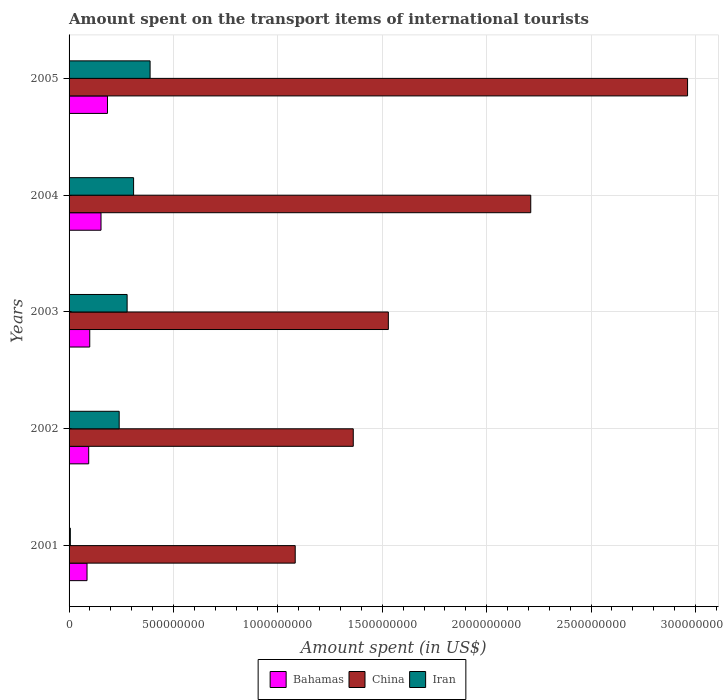How many different coloured bars are there?
Your answer should be compact. 3. How many groups of bars are there?
Make the answer very short. 5. What is the label of the 2nd group of bars from the top?
Give a very brief answer. 2004. In how many cases, is the number of bars for a given year not equal to the number of legend labels?
Provide a short and direct response. 0. What is the amount spent on the transport items of international tourists in Bahamas in 2002?
Ensure brevity in your answer.  9.40e+07. Across all years, what is the maximum amount spent on the transport items of international tourists in China?
Keep it short and to the point. 2.96e+09. Across all years, what is the minimum amount spent on the transport items of international tourists in Bahamas?
Give a very brief answer. 8.60e+07. In which year was the amount spent on the transport items of international tourists in Iran maximum?
Your answer should be very brief. 2005. In which year was the amount spent on the transport items of international tourists in Bahamas minimum?
Keep it short and to the point. 2001. What is the total amount spent on the transport items of international tourists in Iran in the graph?
Give a very brief answer. 1.22e+09. What is the difference between the amount spent on the transport items of international tourists in Bahamas in 2002 and that in 2003?
Make the answer very short. -5.00e+06. What is the difference between the amount spent on the transport items of international tourists in Bahamas in 2005 and the amount spent on the transport items of international tourists in China in 2003?
Keep it short and to the point. -1.34e+09. What is the average amount spent on the transport items of international tourists in Iran per year?
Give a very brief answer. 2.44e+08. In the year 2001, what is the difference between the amount spent on the transport items of international tourists in Iran and amount spent on the transport items of international tourists in Bahamas?
Your answer should be very brief. -8.00e+07. What is the ratio of the amount spent on the transport items of international tourists in Bahamas in 2002 to that in 2005?
Give a very brief answer. 0.51. Is the difference between the amount spent on the transport items of international tourists in Iran in 2002 and 2004 greater than the difference between the amount spent on the transport items of international tourists in Bahamas in 2002 and 2004?
Your answer should be very brief. No. What is the difference between the highest and the second highest amount spent on the transport items of international tourists in China?
Ensure brevity in your answer.  7.51e+08. What is the difference between the highest and the lowest amount spent on the transport items of international tourists in Iran?
Ensure brevity in your answer.  3.82e+08. In how many years, is the amount spent on the transport items of international tourists in China greater than the average amount spent on the transport items of international tourists in China taken over all years?
Your response must be concise. 2. Is the sum of the amount spent on the transport items of international tourists in China in 2001 and 2005 greater than the maximum amount spent on the transport items of international tourists in Bahamas across all years?
Give a very brief answer. Yes. What does the 3rd bar from the top in 2002 represents?
Offer a very short reply. Bahamas. Is it the case that in every year, the sum of the amount spent on the transport items of international tourists in Iran and amount spent on the transport items of international tourists in China is greater than the amount spent on the transport items of international tourists in Bahamas?
Your response must be concise. Yes. How many years are there in the graph?
Offer a terse response. 5. Where does the legend appear in the graph?
Your response must be concise. Bottom center. What is the title of the graph?
Your response must be concise. Amount spent on the transport items of international tourists. What is the label or title of the X-axis?
Your response must be concise. Amount spent (in US$). What is the label or title of the Y-axis?
Provide a succinct answer. Years. What is the Amount spent (in US$) in Bahamas in 2001?
Give a very brief answer. 8.60e+07. What is the Amount spent (in US$) in China in 2001?
Provide a short and direct response. 1.08e+09. What is the Amount spent (in US$) of Iran in 2001?
Make the answer very short. 6.00e+06. What is the Amount spent (in US$) in Bahamas in 2002?
Keep it short and to the point. 9.40e+07. What is the Amount spent (in US$) of China in 2002?
Ensure brevity in your answer.  1.36e+09. What is the Amount spent (in US$) of Iran in 2002?
Your answer should be very brief. 2.40e+08. What is the Amount spent (in US$) in Bahamas in 2003?
Give a very brief answer. 9.90e+07. What is the Amount spent (in US$) of China in 2003?
Ensure brevity in your answer.  1.53e+09. What is the Amount spent (in US$) of Iran in 2003?
Offer a very short reply. 2.78e+08. What is the Amount spent (in US$) in Bahamas in 2004?
Your answer should be compact. 1.53e+08. What is the Amount spent (in US$) in China in 2004?
Provide a short and direct response. 2.21e+09. What is the Amount spent (in US$) in Iran in 2004?
Give a very brief answer. 3.09e+08. What is the Amount spent (in US$) in Bahamas in 2005?
Make the answer very short. 1.84e+08. What is the Amount spent (in US$) in China in 2005?
Provide a succinct answer. 2.96e+09. What is the Amount spent (in US$) in Iran in 2005?
Offer a very short reply. 3.88e+08. Across all years, what is the maximum Amount spent (in US$) in Bahamas?
Give a very brief answer. 1.84e+08. Across all years, what is the maximum Amount spent (in US$) of China?
Offer a very short reply. 2.96e+09. Across all years, what is the maximum Amount spent (in US$) in Iran?
Give a very brief answer. 3.88e+08. Across all years, what is the minimum Amount spent (in US$) in Bahamas?
Your response must be concise. 8.60e+07. Across all years, what is the minimum Amount spent (in US$) in China?
Offer a terse response. 1.08e+09. Across all years, what is the minimum Amount spent (in US$) in Iran?
Offer a terse response. 6.00e+06. What is the total Amount spent (in US$) of Bahamas in the graph?
Offer a very short reply. 6.16e+08. What is the total Amount spent (in US$) in China in the graph?
Your answer should be compact. 9.15e+09. What is the total Amount spent (in US$) in Iran in the graph?
Ensure brevity in your answer.  1.22e+09. What is the difference between the Amount spent (in US$) in Bahamas in 2001 and that in 2002?
Offer a very short reply. -8.00e+06. What is the difference between the Amount spent (in US$) in China in 2001 and that in 2002?
Your answer should be very brief. -2.78e+08. What is the difference between the Amount spent (in US$) in Iran in 2001 and that in 2002?
Make the answer very short. -2.34e+08. What is the difference between the Amount spent (in US$) of Bahamas in 2001 and that in 2003?
Provide a succinct answer. -1.30e+07. What is the difference between the Amount spent (in US$) in China in 2001 and that in 2003?
Provide a short and direct response. -4.46e+08. What is the difference between the Amount spent (in US$) of Iran in 2001 and that in 2003?
Provide a succinct answer. -2.72e+08. What is the difference between the Amount spent (in US$) of Bahamas in 2001 and that in 2004?
Your answer should be very brief. -6.70e+07. What is the difference between the Amount spent (in US$) in China in 2001 and that in 2004?
Give a very brief answer. -1.13e+09. What is the difference between the Amount spent (in US$) in Iran in 2001 and that in 2004?
Provide a succinct answer. -3.03e+08. What is the difference between the Amount spent (in US$) of Bahamas in 2001 and that in 2005?
Provide a succinct answer. -9.80e+07. What is the difference between the Amount spent (in US$) of China in 2001 and that in 2005?
Ensure brevity in your answer.  -1.88e+09. What is the difference between the Amount spent (in US$) of Iran in 2001 and that in 2005?
Give a very brief answer. -3.82e+08. What is the difference between the Amount spent (in US$) in Bahamas in 2002 and that in 2003?
Offer a terse response. -5.00e+06. What is the difference between the Amount spent (in US$) of China in 2002 and that in 2003?
Keep it short and to the point. -1.68e+08. What is the difference between the Amount spent (in US$) of Iran in 2002 and that in 2003?
Make the answer very short. -3.80e+07. What is the difference between the Amount spent (in US$) of Bahamas in 2002 and that in 2004?
Your answer should be very brief. -5.90e+07. What is the difference between the Amount spent (in US$) of China in 2002 and that in 2004?
Make the answer very short. -8.50e+08. What is the difference between the Amount spent (in US$) in Iran in 2002 and that in 2004?
Give a very brief answer. -6.90e+07. What is the difference between the Amount spent (in US$) in Bahamas in 2002 and that in 2005?
Provide a succinct answer. -9.00e+07. What is the difference between the Amount spent (in US$) in China in 2002 and that in 2005?
Your response must be concise. -1.60e+09. What is the difference between the Amount spent (in US$) of Iran in 2002 and that in 2005?
Your answer should be compact. -1.48e+08. What is the difference between the Amount spent (in US$) in Bahamas in 2003 and that in 2004?
Ensure brevity in your answer.  -5.40e+07. What is the difference between the Amount spent (in US$) of China in 2003 and that in 2004?
Give a very brief answer. -6.82e+08. What is the difference between the Amount spent (in US$) of Iran in 2003 and that in 2004?
Your response must be concise. -3.10e+07. What is the difference between the Amount spent (in US$) of Bahamas in 2003 and that in 2005?
Provide a succinct answer. -8.50e+07. What is the difference between the Amount spent (in US$) in China in 2003 and that in 2005?
Ensure brevity in your answer.  -1.43e+09. What is the difference between the Amount spent (in US$) in Iran in 2003 and that in 2005?
Offer a terse response. -1.10e+08. What is the difference between the Amount spent (in US$) of Bahamas in 2004 and that in 2005?
Offer a very short reply. -3.10e+07. What is the difference between the Amount spent (in US$) of China in 2004 and that in 2005?
Provide a short and direct response. -7.51e+08. What is the difference between the Amount spent (in US$) of Iran in 2004 and that in 2005?
Keep it short and to the point. -7.90e+07. What is the difference between the Amount spent (in US$) of Bahamas in 2001 and the Amount spent (in US$) of China in 2002?
Offer a very short reply. -1.28e+09. What is the difference between the Amount spent (in US$) in Bahamas in 2001 and the Amount spent (in US$) in Iran in 2002?
Ensure brevity in your answer.  -1.54e+08. What is the difference between the Amount spent (in US$) of China in 2001 and the Amount spent (in US$) of Iran in 2002?
Provide a succinct answer. 8.43e+08. What is the difference between the Amount spent (in US$) in Bahamas in 2001 and the Amount spent (in US$) in China in 2003?
Keep it short and to the point. -1.44e+09. What is the difference between the Amount spent (in US$) of Bahamas in 2001 and the Amount spent (in US$) of Iran in 2003?
Offer a terse response. -1.92e+08. What is the difference between the Amount spent (in US$) of China in 2001 and the Amount spent (in US$) of Iran in 2003?
Make the answer very short. 8.05e+08. What is the difference between the Amount spent (in US$) of Bahamas in 2001 and the Amount spent (in US$) of China in 2004?
Your answer should be compact. -2.12e+09. What is the difference between the Amount spent (in US$) in Bahamas in 2001 and the Amount spent (in US$) in Iran in 2004?
Your response must be concise. -2.23e+08. What is the difference between the Amount spent (in US$) in China in 2001 and the Amount spent (in US$) in Iran in 2004?
Keep it short and to the point. 7.74e+08. What is the difference between the Amount spent (in US$) in Bahamas in 2001 and the Amount spent (in US$) in China in 2005?
Offer a very short reply. -2.88e+09. What is the difference between the Amount spent (in US$) in Bahamas in 2001 and the Amount spent (in US$) in Iran in 2005?
Offer a very short reply. -3.02e+08. What is the difference between the Amount spent (in US$) in China in 2001 and the Amount spent (in US$) in Iran in 2005?
Provide a short and direct response. 6.95e+08. What is the difference between the Amount spent (in US$) in Bahamas in 2002 and the Amount spent (in US$) in China in 2003?
Offer a terse response. -1.44e+09. What is the difference between the Amount spent (in US$) of Bahamas in 2002 and the Amount spent (in US$) of Iran in 2003?
Ensure brevity in your answer.  -1.84e+08. What is the difference between the Amount spent (in US$) of China in 2002 and the Amount spent (in US$) of Iran in 2003?
Provide a succinct answer. 1.08e+09. What is the difference between the Amount spent (in US$) in Bahamas in 2002 and the Amount spent (in US$) in China in 2004?
Offer a very short reply. -2.12e+09. What is the difference between the Amount spent (in US$) of Bahamas in 2002 and the Amount spent (in US$) of Iran in 2004?
Make the answer very short. -2.15e+08. What is the difference between the Amount spent (in US$) in China in 2002 and the Amount spent (in US$) in Iran in 2004?
Provide a succinct answer. 1.05e+09. What is the difference between the Amount spent (in US$) of Bahamas in 2002 and the Amount spent (in US$) of China in 2005?
Make the answer very short. -2.87e+09. What is the difference between the Amount spent (in US$) of Bahamas in 2002 and the Amount spent (in US$) of Iran in 2005?
Provide a succinct answer. -2.94e+08. What is the difference between the Amount spent (in US$) of China in 2002 and the Amount spent (in US$) of Iran in 2005?
Ensure brevity in your answer.  9.73e+08. What is the difference between the Amount spent (in US$) in Bahamas in 2003 and the Amount spent (in US$) in China in 2004?
Make the answer very short. -2.11e+09. What is the difference between the Amount spent (in US$) in Bahamas in 2003 and the Amount spent (in US$) in Iran in 2004?
Provide a succinct answer. -2.10e+08. What is the difference between the Amount spent (in US$) in China in 2003 and the Amount spent (in US$) in Iran in 2004?
Keep it short and to the point. 1.22e+09. What is the difference between the Amount spent (in US$) in Bahamas in 2003 and the Amount spent (in US$) in China in 2005?
Provide a succinct answer. -2.86e+09. What is the difference between the Amount spent (in US$) of Bahamas in 2003 and the Amount spent (in US$) of Iran in 2005?
Ensure brevity in your answer.  -2.89e+08. What is the difference between the Amount spent (in US$) of China in 2003 and the Amount spent (in US$) of Iran in 2005?
Your answer should be compact. 1.14e+09. What is the difference between the Amount spent (in US$) in Bahamas in 2004 and the Amount spent (in US$) in China in 2005?
Give a very brief answer. -2.81e+09. What is the difference between the Amount spent (in US$) in Bahamas in 2004 and the Amount spent (in US$) in Iran in 2005?
Your answer should be very brief. -2.35e+08. What is the difference between the Amount spent (in US$) in China in 2004 and the Amount spent (in US$) in Iran in 2005?
Offer a very short reply. 1.82e+09. What is the average Amount spent (in US$) of Bahamas per year?
Provide a succinct answer. 1.23e+08. What is the average Amount spent (in US$) of China per year?
Offer a very short reply. 1.83e+09. What is the average Amount spent (in US$) of Iran per year?
Offer a very short reply. 2.44e+08. In the year 2001, what is the difference between the Amount spent (in US$) in Bahamas and Amount spent (in US$) in China?
Ensure brevity in your answer.  -9.97e+08. In the year 2001, what is the difference between the Amount spent (in US$) in Bahamas and Amount spent (in US$) in Iran?
Offer a very short reply. 8.00e+07. In the year 2001, what is the difference between the Amount spent (in US$) in China and Amount spent (in US$) in Iran?
Offer a very short reply. 1.08e+09. In the year 2002, what is the difference between the Amount spent (in US$) of Bahamas and Amount spent (in US$) of China?
Keep it short and to the point. -1.27e+09. In the year 2002, what is the difference between the Amount spent (in US$) of Bahamas and Amount spent (in US$) of Iran?
Offer a terse response. -1.46e+08. In the year 2002, what is the difference between the Amount spent (in US$) in China and Amount spent (in US$) in Iran?
Keep it short and to the point. 1.12e+09. In the year 2003, what is the difference between the Amount spent (in US$) of Bahamas and Amount spent (in US$) of China?
Your answer should be very brief. -1.43e+09. In the year 2003, what is the difference between the Amount spent (in US$) in Bahamas and Amount spent (in US$) in Iran?
Your response must be concise. -1.79e+08. In the year 2003, what is the difference between the Amount spent (in US$) of China and Amount spent (in US$) of Iran?
Provide a short and direct response. 1.25e+09. In the year 2004, what is the difference between the Amount spent (in US$) of Bahamas and Amount spent (in US$) of China?
Offer a very short reply. -2.06e+09. In the year 2004, what is the difference between the Amount spent (in US$) in Bahamas and Amount spent (in US$) in Iran?
Your answer should be very brief. -1.56e+08. In the year 2004, what is the difference between the Amount spent (in US$) in China and Amount spent (in US$) in Iran?
Your answer should be compact. 1.90e+09. In the year 2005, what is the difference between the Amount spent (in US$) of Bahamas and Amount spent (in US$) of China?
Your response must be concise. -2.78e+09. In the year 2005, what is the difference between the Amount spent (in US$) of Bahamas and Amount spent (in US$) of Iran?
Offer a very short reply. -2.04e+08. In the year 2005, what is the difference between the Amount spent (in US$) in China and Amount spent (in US$) in Iran?
Give a very brief answer. 2.57e+09. What is the ratio of the Amount spent (in US$) of Bahamas in 2001 to that in 2002?
Provide a succinct answer. 0.91. What is the ratio of the Amount spent (in US$) in China in 2001 to that in 2002?
Offer a very short reply. 0.8. What is the ratio of the Amount spent (in US$) of Iran in 2001 to that in 2002?
Offer a very short reply. 0.03. What is the ratio of the Amount spent (in US$) of Bahamas in 2001 to that in 2003?
Offer a terse response. 0.87. What is the ratio of the Amount spent (in US$) of China in 2001 to that in 2003?
Make the answer very short. 0.71. What is the ratio of the Amount spent (in US$) of Iran in 2001 to that in 2003?
Offer a very short reply. 0.02. What is the ratio of the Amount spent (in US$) of Bahamas in 2001 to that in 2004?
Give a very brief answer. 0.56. What is the ratio of the Amount spent (in US$) of China in 2001 to that in 2004?
Give a very brief answer. 0.49. What is the ratio of the Amount spent (in US$) of Iran in 2001 to that in 2004?
Keep it short and to the point. 0.02. What is the ratio of the Amount spent (in US$) of Bahamas in 2001 to that in 2005?
Give a very brief answer. 0.47. What is the ratio of the Amount spent (in US$) of China in 2001 to that in 2005?
Ensure brevity in your answer.  0.37. What is the ratio of the Amount spent (in US$) in Iran in 2001 to that in 2005?
Provide a short and direct response. 0.02. What is the ratio of the Amount spent (in US$) in Bahamas in 2002 to that in 2003?
Your response must be concise. 0.95. What is the ratio of the Amount spent (in US$) in China in 2002 to that in 2003?
Give a very brief answer. 0.89. What is the ratio of the Amount spent (in US$) of Iran in 2002 to that in 2003?
Provide a short and direct response. 0.86. What is the ratio of the Amount spent (in US$) in Bahamas in 2002 to that in 2004?
Your answer should be very brief. 0.61. What is the ratio of the Amount spent (in US$) in China in 2002 to that in 2004?
Your answer should be compact. 0.62. What is the ratio of the Amount spent (in US$) in Iran in 2002 to that in 2004?
Provide a succinct answer. 0.78. What is the ratio of the Amount spent (in US$) in Bahamas in 2002 to that in 2005?
Your response must be concise. 0.51. What is the ratio of the Amount spent (in US$) of China in 2002 to that in 2005?
Offer a terse response. 0.46. What is the ratio of the Amount spent (in US$) of Iran in 2002 to that in 2005?
Your answer should be very brief. 0.62. What is the ratio of the Amount spent (in US$) of Bahamas in 2003 to that in 2004?
Keep it short and to the point. 0.65. What is the ratio of the Amount spent (in US$) in China in 2003 to that in 2004?
Give a very brief answer. 0.69. What is the ratio of the Amount spent (in US$) of Iran in 2003 to that in 2004?
Provide a short and direct response. 0.9. What is the ratio of the Amount spent (in US$) of Bahamas in 2003 to that in 2005?
Make the answer very short. 0.54. What is the ratio of the Amount spent (in US$) in China in 2003 to that in 2005?
Make the answer very short. 0.52. What is the ratio of the Amount spent (in US$) in Iran in 2003 to that in 2005?
Offer a terse response. 0.72. What is the ratio of the Amount spent (in US$) of Bahamas in 2004 to that in 2005?
Your answer should be compact. 0.83. What is the ratio of the Amount spent (in US$) in China in 2004 to that in 2005?
Keep it short and to the point. 0.75. What is the ratio of the Amount spent (in US$) in Iran in 2004 to that in 2005?
Your response must be concise. 0.8. What is the difference between the highest and the second highest Amount spent (in US$) of Bahamas?
Keep it short and to the point. 3.10e+07. What is the difference between the highest and the second highest Amount spent (in US$) in China?
Offer a very short reply. 7.51e+08. What is the difference between the highest and the second highest Amount spent (in US$) in Iran?
Offer a terse response. 7.90e+07. What is the difference between the highest and the lowest Amount spent (in US$) in Bahamas?
Your answer should be very brief. 9.80e+07. What is the difference between the highest and the lowest Amount spent (in US$) of China?
Ensure brevity in your answer.  1.88e+09. What is the difference between the highest and the lowest Amount spent (in US$) of Iran?
Your answer should be very brief. 3.82e+08. 